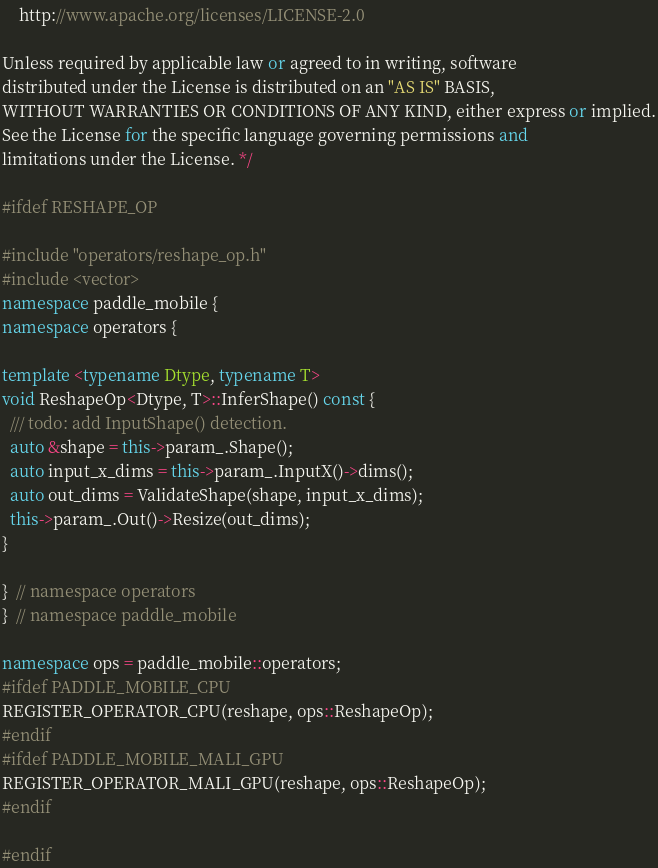<code> <loc_0><loc_0><loc_500><loc_500><_C++_>
    http://www.apache.org/licenses/LICENSE-2.0

Unless required by applicable law or agreed to in writing, software
distributed under the License is distributed on an "AS IS" BASIS,
WITHOUT WARRANTIES OR CONDITIONS OF ANY KIND, either express or implied.
See the License for the specific language governing permissions and
limitations under the License. */

#ifdef RESHAPE_OP

#include "operators/reshape_op.h"
#include <vector>
namespace paddle_mobile {
namespace operators {

template <typename Dtype, typename T>
void ReshapeOp<Dtype, T>::InferShape() const {
  /// todo: add InputShape() detection.
  auto &shape = this->param_.Shape();
  auto input_x_dims = this->param_.InputX()->dims();
  auto out_dims = ValidateShape(shape, input_x_dims);
  this->param_.Out()->Resize(out_dims);
}

}  // namespace operators
}  // namespace paddle_mobile

namespace ops = paddle_mobile::operators;
#ifdef PADDLE_MOBILE_CPU
REGISTER_OPERATOR_CPU(reshape, ops::ReshapeOp);
#endif
#ifdef PADDLE_MOBILE_MALI_GPU
REGISTER_OPERATOR_MALI_GPU(reshape, ops::ReshapeOp);
#endif

#endif
</code> 